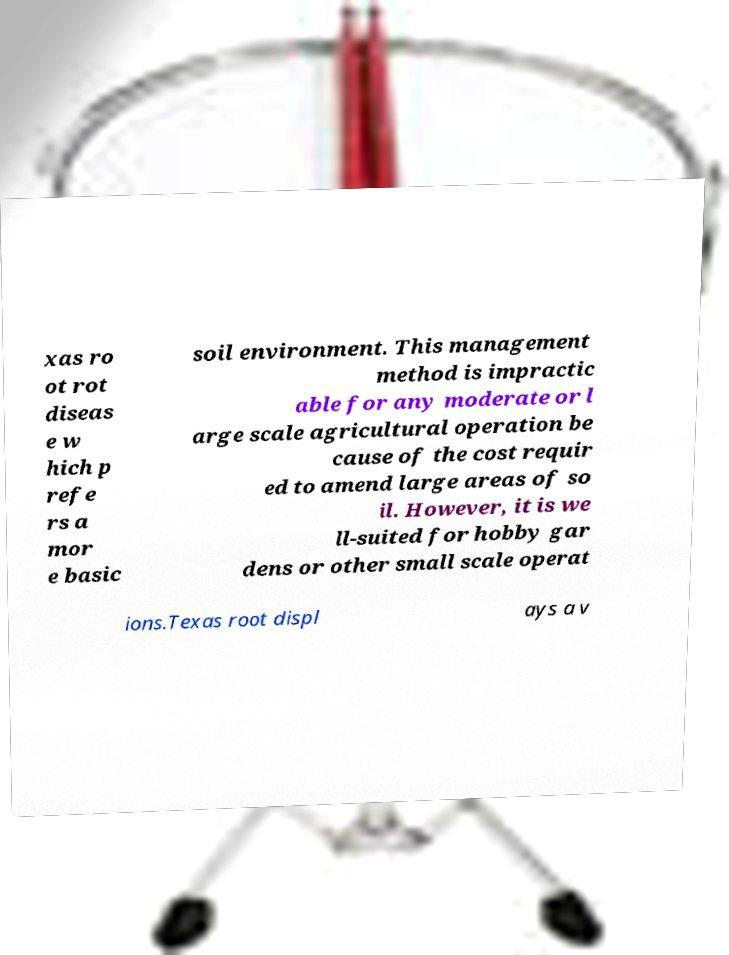Please read and relay the text visible in this image. What does it say? xas ro ot rot diseas e w hich p refe rs a mor e basic soil environment. This management method is impractic able for any moderate or l arge scale agricultural operation be cause of the cost requir ed to amend large areas of so il. However, it is we ll-suited for hobby gar dens or other small scale operat ions.Texas root displ ays a v 